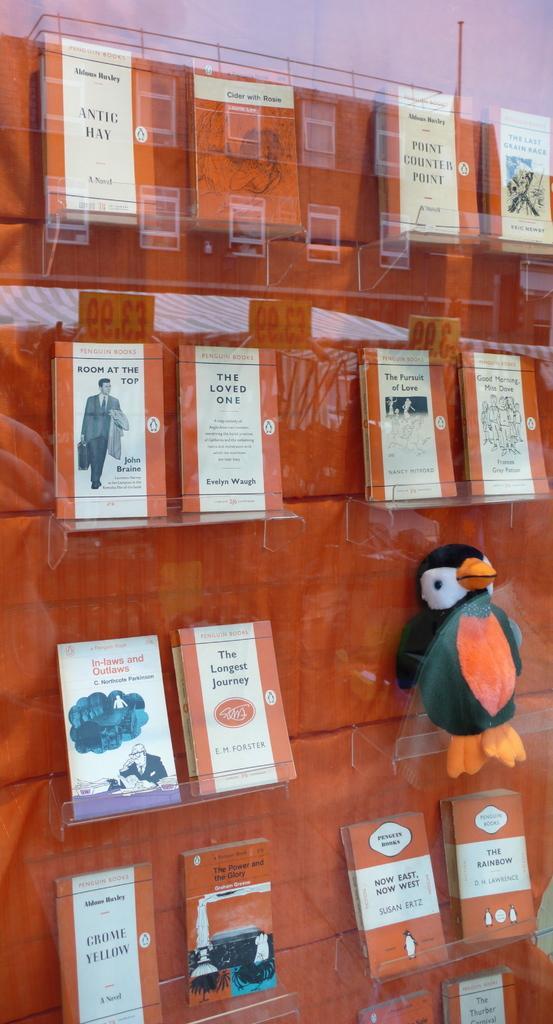Describe this image in one or two sentences. In this image I can see there are books in the glass racks. On the right side there is the doll in the shape of a bird. 